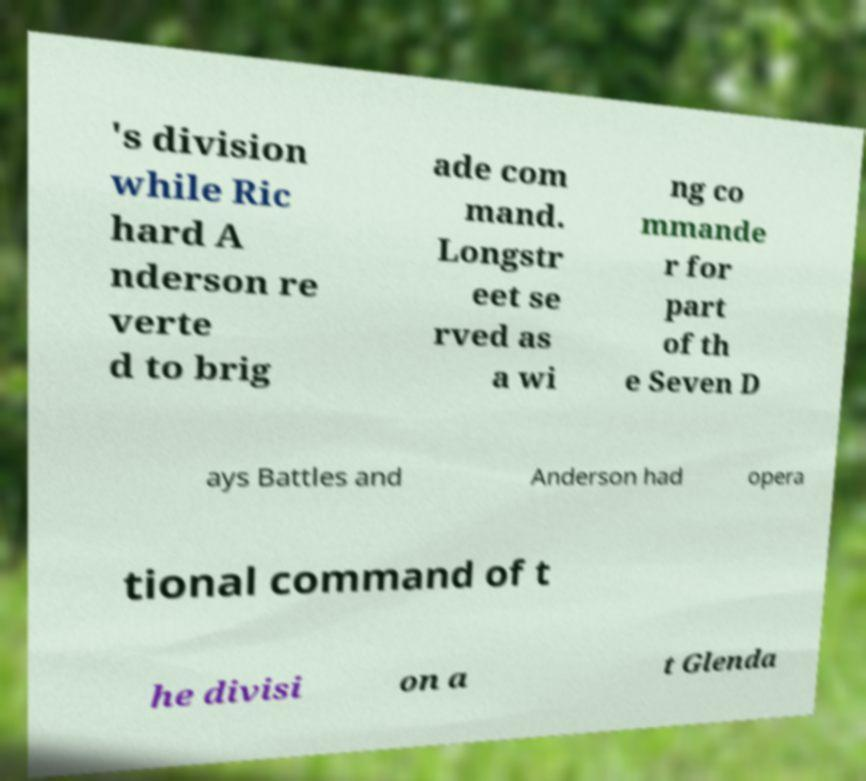For documentation purposes, I need the text within this image transcribed. Could you provide that? 's division while Ric hard A nderson re verte d to brig ade com mand. Longstr eet se rved as a wi ng co mmande r for part of th e Seven D ays Battles and Anderson had opera tional command of t he divisi on a t Glenda 